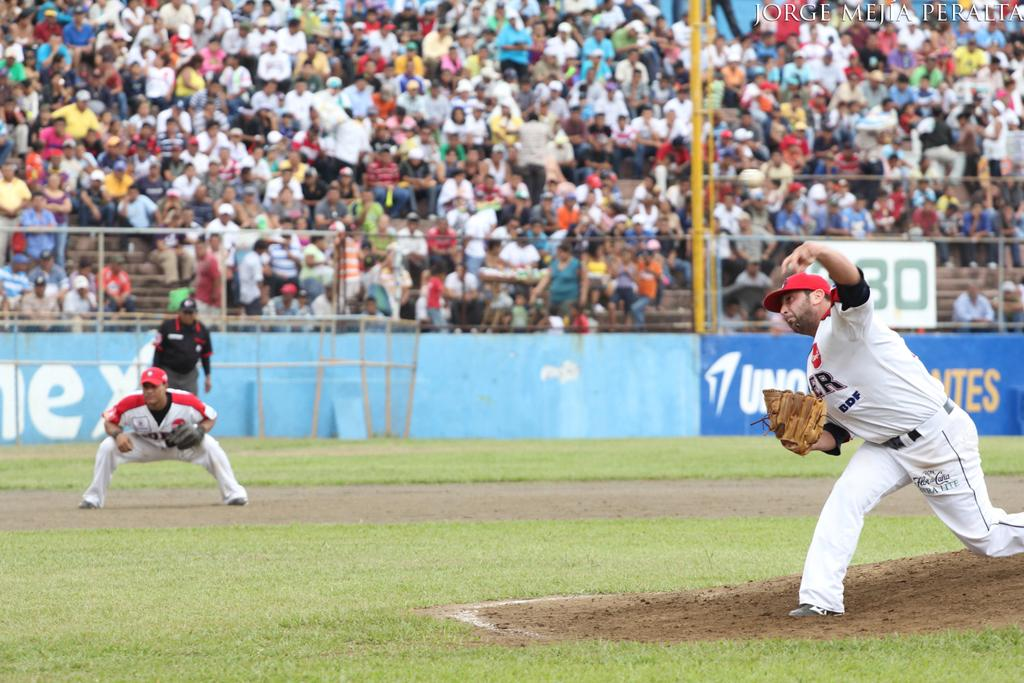<image>
Give a short and clear explanation of the subsequent image. a baseball player for DDF with a mitt on the field with a crowd in the bleachers 